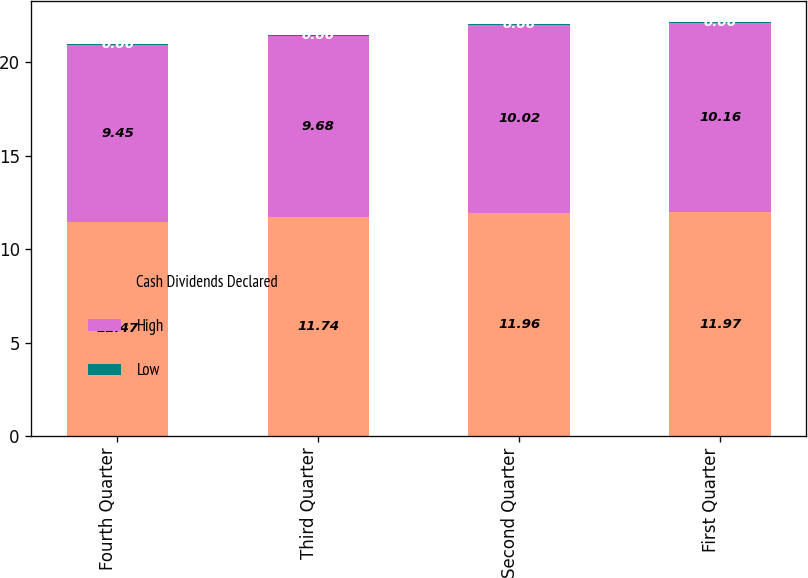Convert chart. <chart><loc_0><loc_0><loc_500><loc_500><stacked_bar_chart><ecel><fcel>Fourth Quarter<fcel>Third Quarter<fcel>Second Quarter<fcel>First Quarter<nl><fcel>Cash Dividends Declared<fcel>11.47<fcel>11.74<fcel>11.96<fcel>11.97<nl><fcel>High<fcel>9.45<fcel>9.68<fcel>10.02<fcel>10.16<nl><fcel>Low<fcel>0.06<fcel>0.06<fcel>0.06<fcel>0.06<nl></chart> 